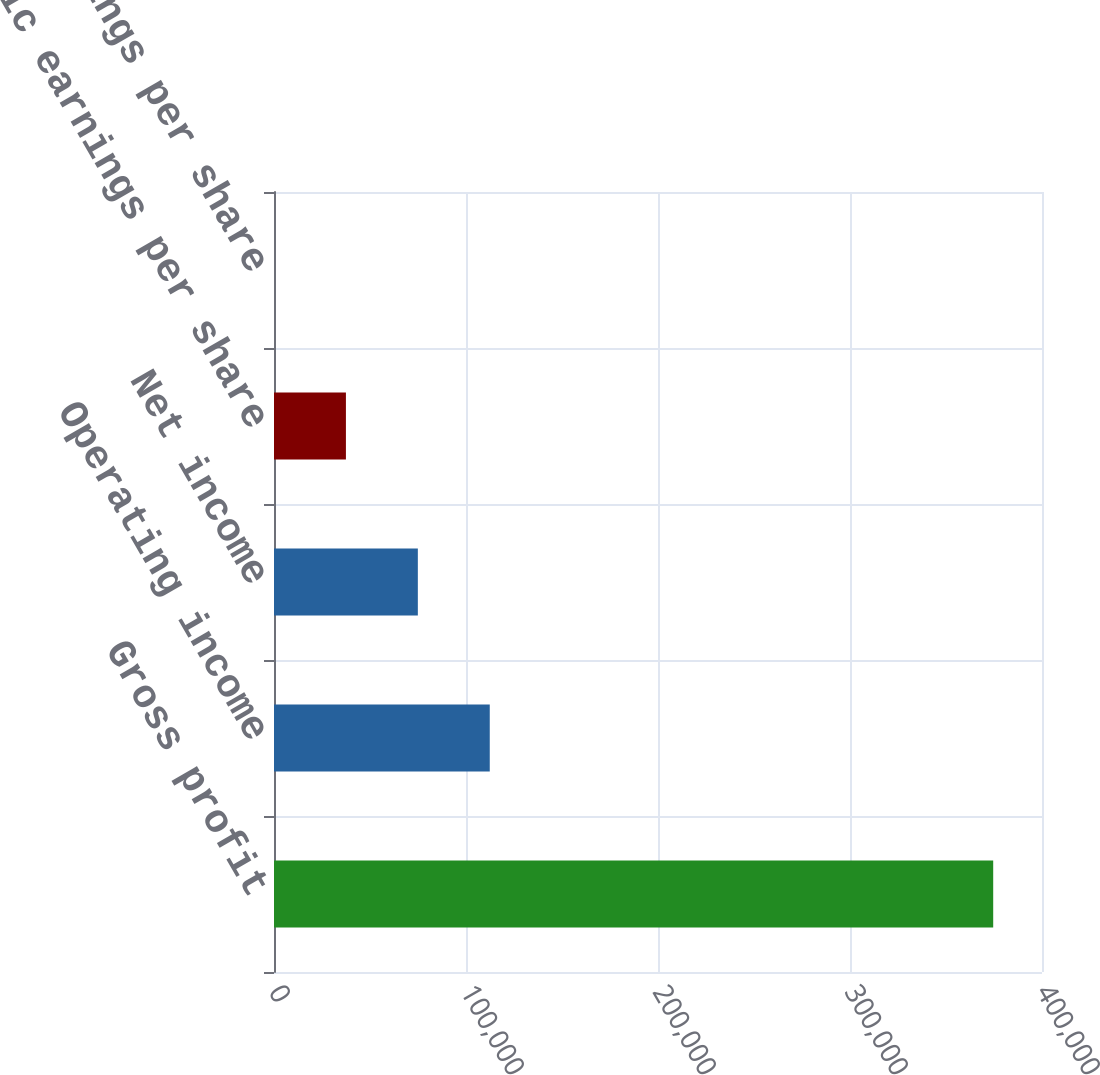Convert chart. <chart><loc_0><loc_0><loc_500><loc_500><bar_chart><fcel>Gross profit<fcel>Operating income<fcel>Net income<fcel>Basic earnings per share<fcel>Diluted earnings per share<nl><fcel>374584<fcel>112375<fcel>74916.8<fcel>37458.4<fcel>0.06<nl></chart> 